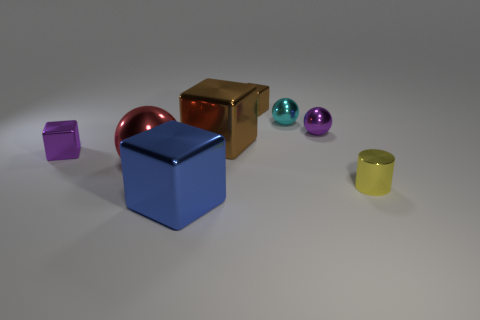Add 2 balls. How many objects exist? 10 Subtract all tiny purple cubes. How many cubes are left? 3 Subtract all brown cylinders. How many brown cubes are left? 2 Subtract all blue cubes. How many cubes are left? 3 Subtract all cylinders. How many objects are left? 7 Add 5 big red metallic objects. How many big red metallic objects are left? 6 Add 4 brown objects. How many brown objects exist? 6 Subtract 1 cyan spheres. How many objects are left? 7 Subtract all yellow balls. Subtract all brown blocks. How many balls are left? 3 Subtract all small yellow things. Subtract all red metallic things. How many objects are left? 6 